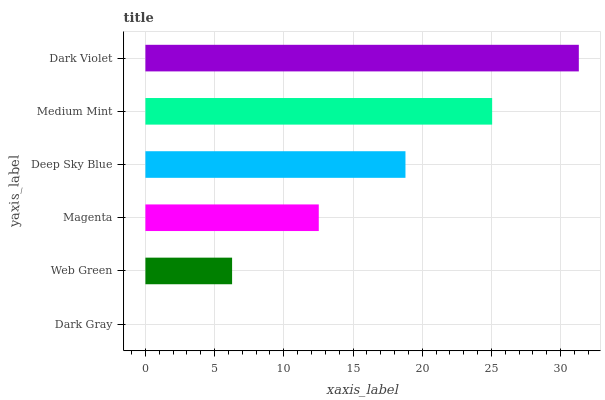Is Dark Gray the minimum?
Answer yes or no. Yes. Is Dark Violet the maximum?
Answer yes or no. Yes. Is Web Green the minimum?
Answer yes or no. No. Is Web Green the maximum?
Answer yes or no. No. Is Web Green greater than Dark Gray?
Answer yes or no. Yes. Is Dark Gray less than Web Green?
Answer yes or no. Yes. Is Dark Gray greater than Web Green?
Answer yes or no. No. Is Web Green less than Dark Gray?
Answer yes or no. No. Is Deep Sky Blue the high median?
Answer yes or no. Yes. Is Magenta the low median?
Answer yes or no. Yes. Is Dark Gray the high median?
Answer yes or no. No. Is Web Green the low median?
Answer yes or no. No. 